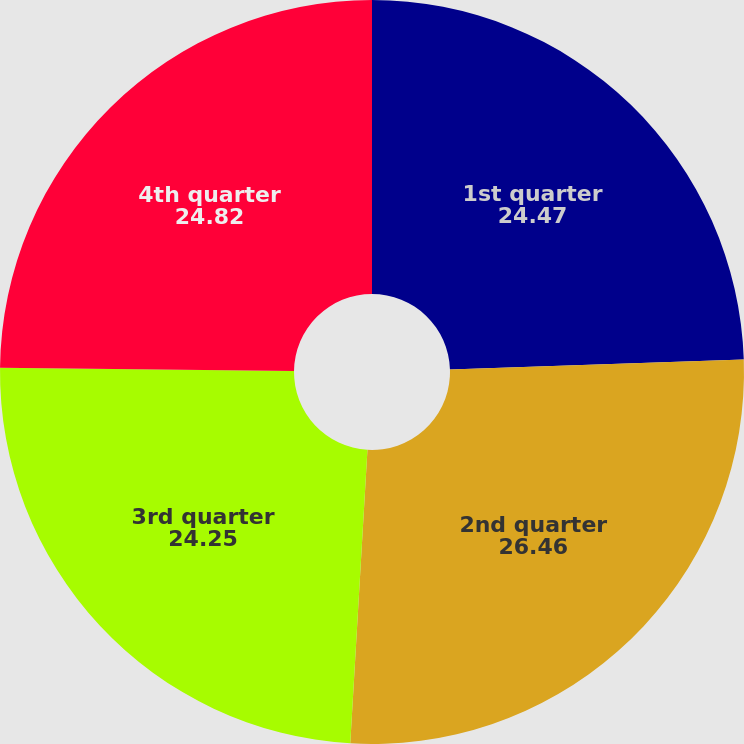Convert chart. <chart><loc_0><loc_0><loc_500><loc_500><pie_chart><fcel>1st quarter<fcel>2nd quarter<fcel>3rd quarter<fcel>4th quarter<nl><fcel>24.47%<fcel>26.46%<fcel>24.25%<fcel>24.82%<nl></chart> 